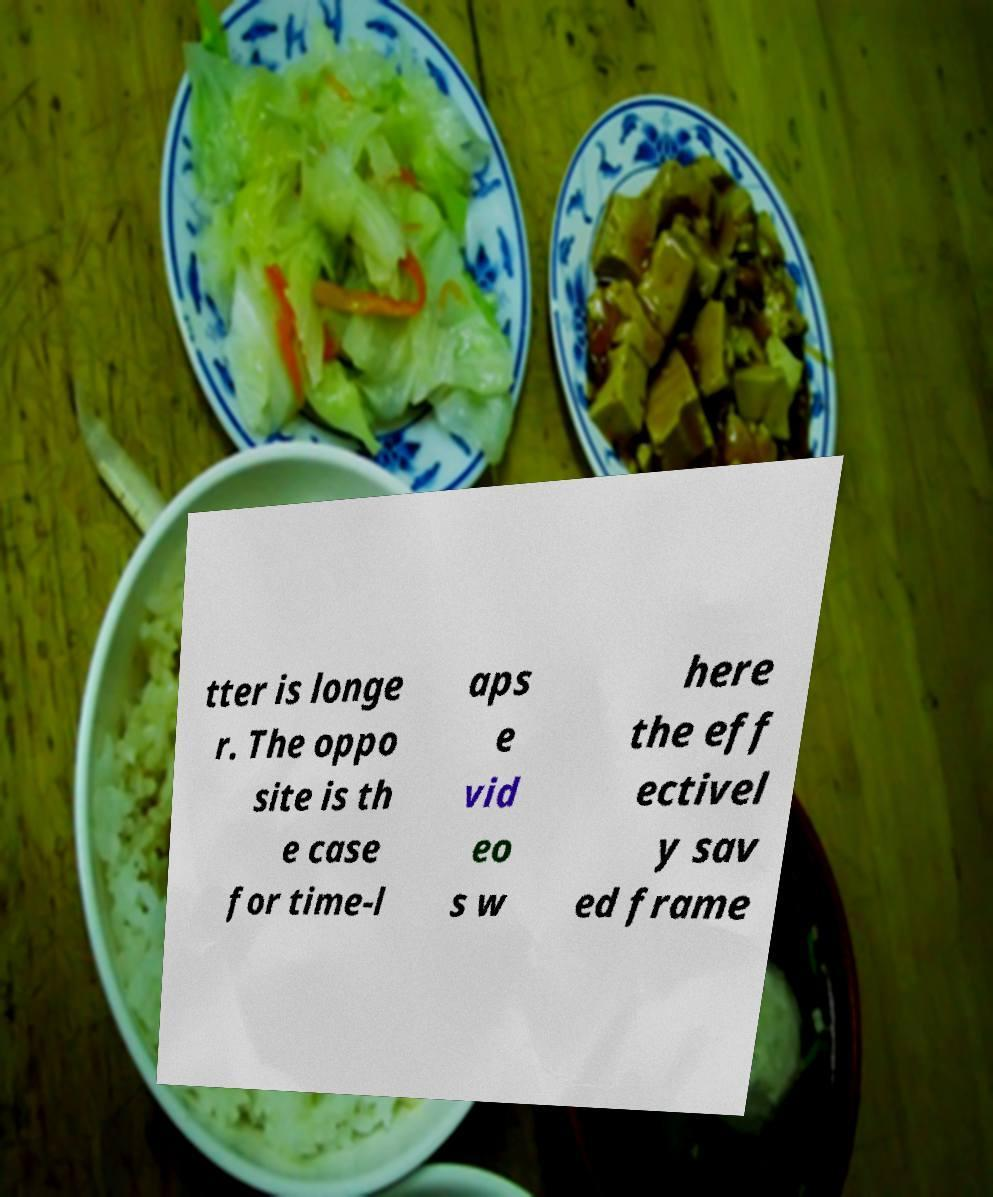I need the written content from this picture converted into text. Can you do that? tter is longe r. The oppo site is th e case for time-l aps e vid eo s w here the eff ectivel y sav ed frame 